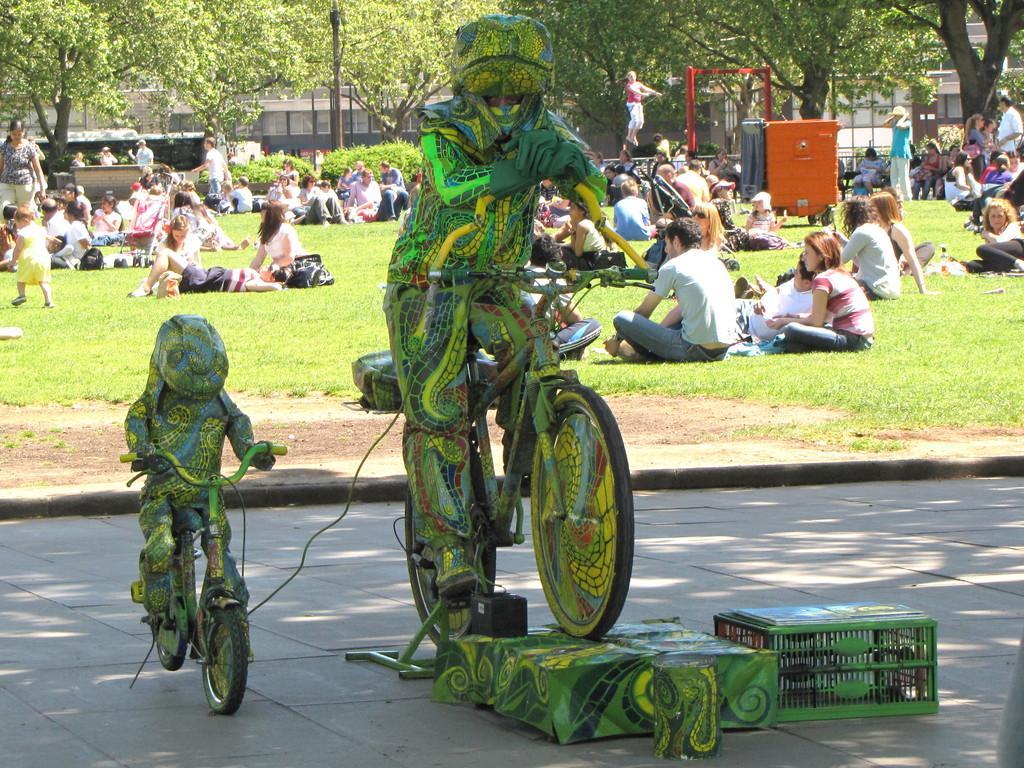Could you give a brief overview of what you see in this image? In this image there is a sculpture of person riding bicycle with boxes under that, behind that there is a grass fields where people are sitting and standing also there are so many buildings and trees. 